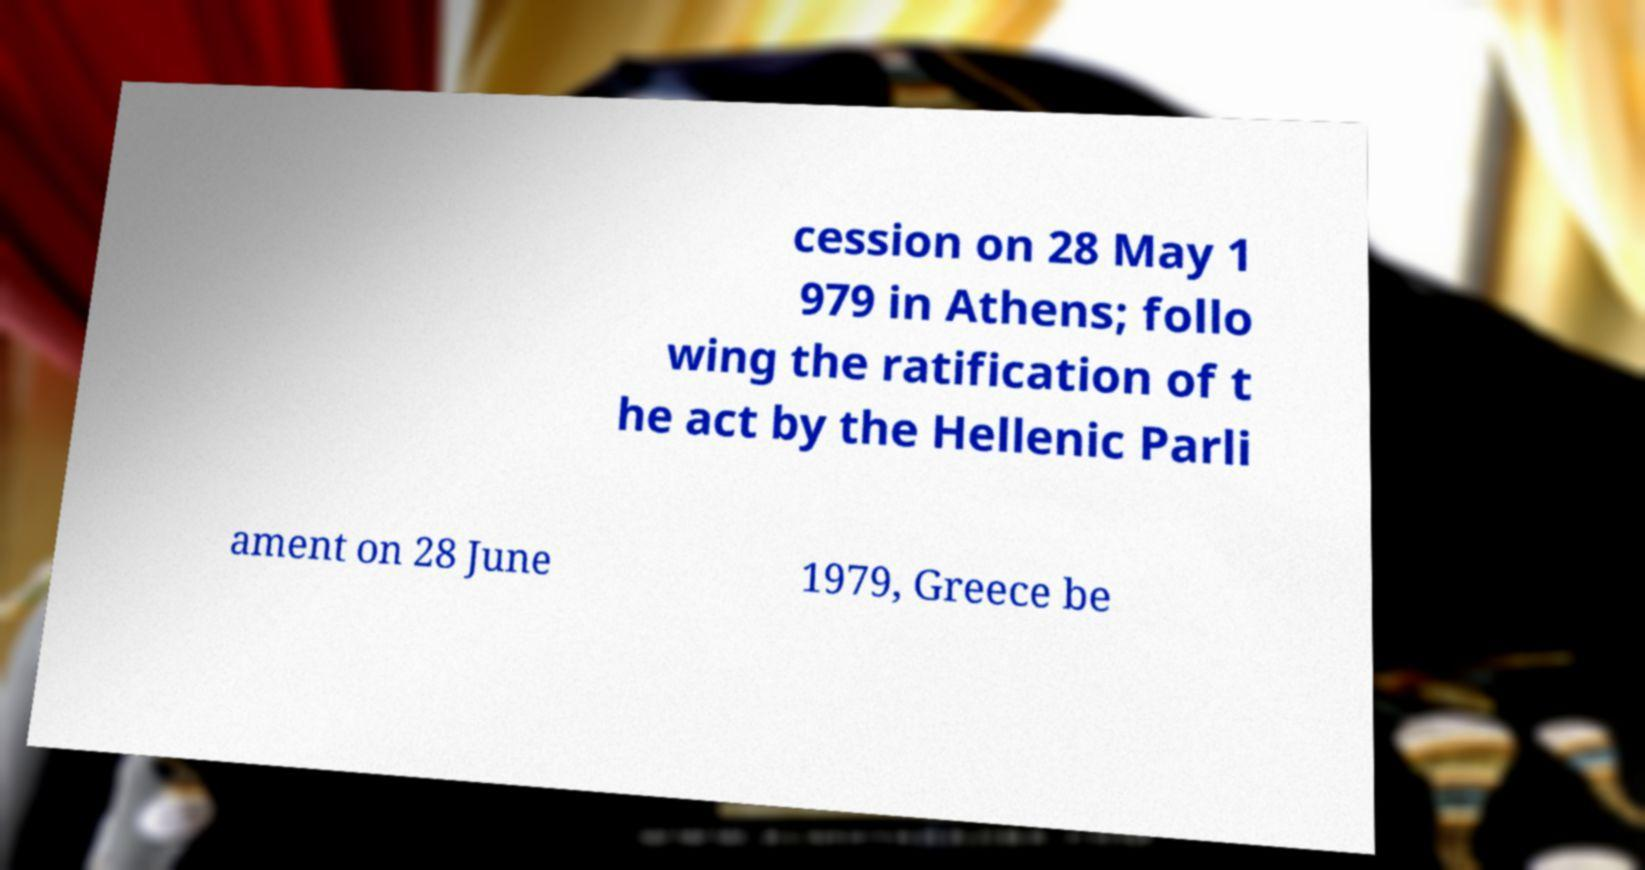Please read and relay the text visible in this image. What does it say? cession on 28 May 1 979 in Athens; follo wing the ratification of t he act by the Hellenic Parli ament on 28 June 1979, Greece be 